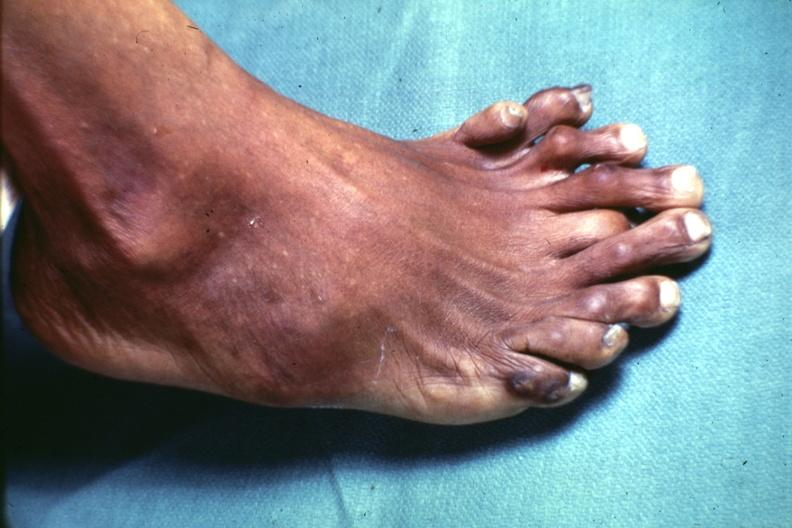re view looking down on heads present?
Answer the question using a single word or phrase. No 